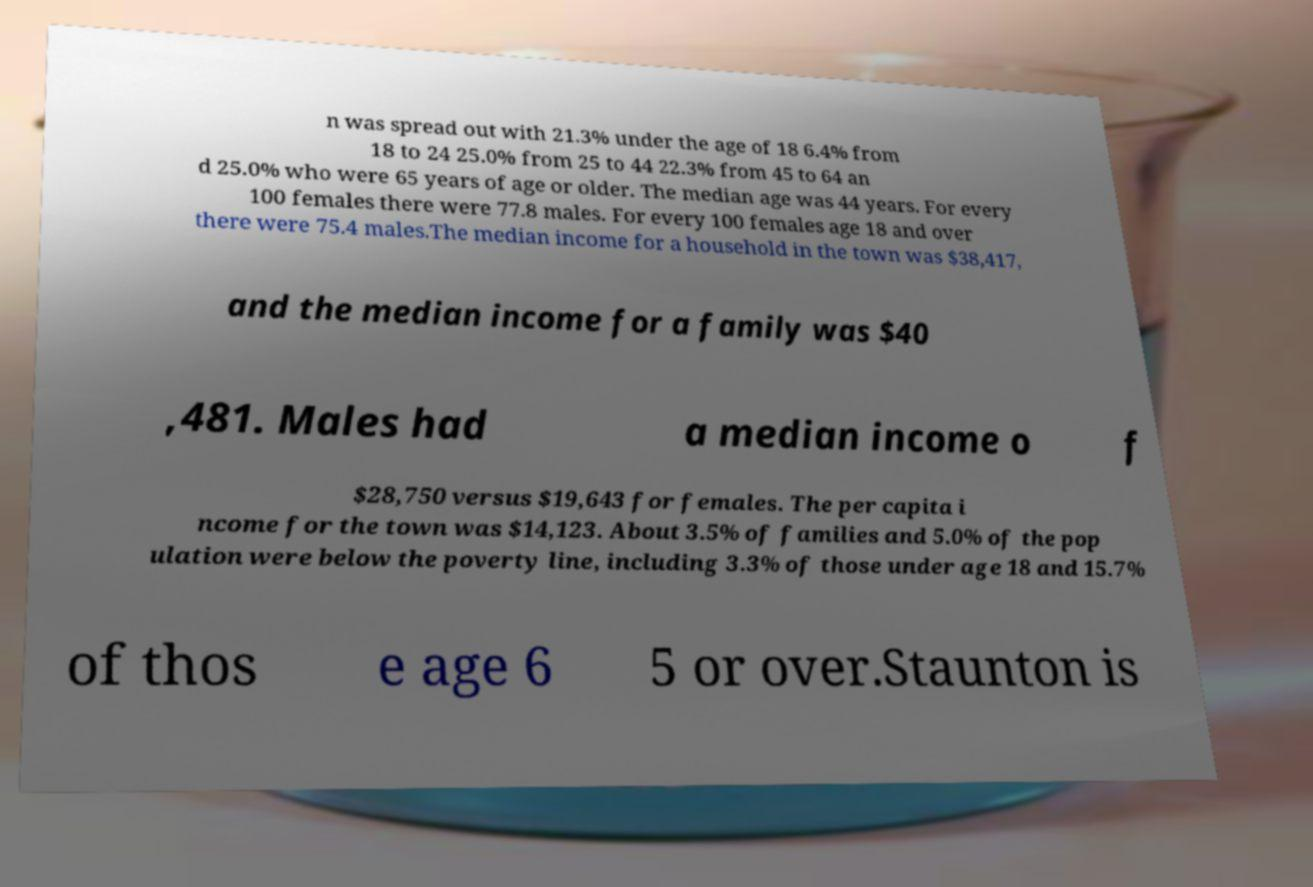Please identify and transcribe the text found in this image. n was spread out with 21.3% under the age of 18 6.4% from 18 to 24 25.0% from 25 to 44 22.3% from 45 to 64 an d 25.0% who were 65 years of age or older. The median age was 44 years. For every 100 females there were 77.8 males. For every 100 females age 18 and over there were 75.4 males.The median income for a household in the town was $38,417, and the median income for a family was $40 ,481. Males had a median income o f $28,750 versus $19,643 for females. The per capita i ncome for the town was $14,123. About 3.5% of families and 5.0% of the pop ulation were below the poverty line, including 3.3% of those under age 18 and 15.7% of thos e age 6 5 or over.Staunton is 